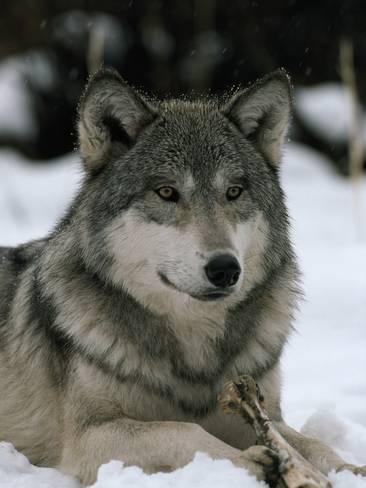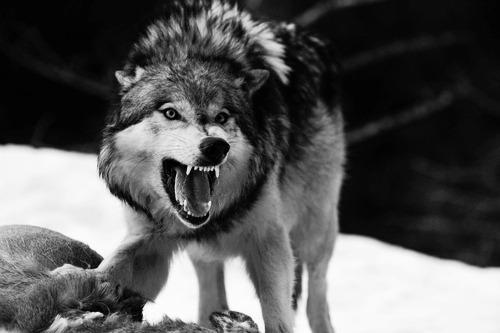The first image is the image on the left, the second image is the image on the right. Considering the images on both sides, is "The wolf in the image on the right has its mouth closed." valid? Answer yes or no. No. 